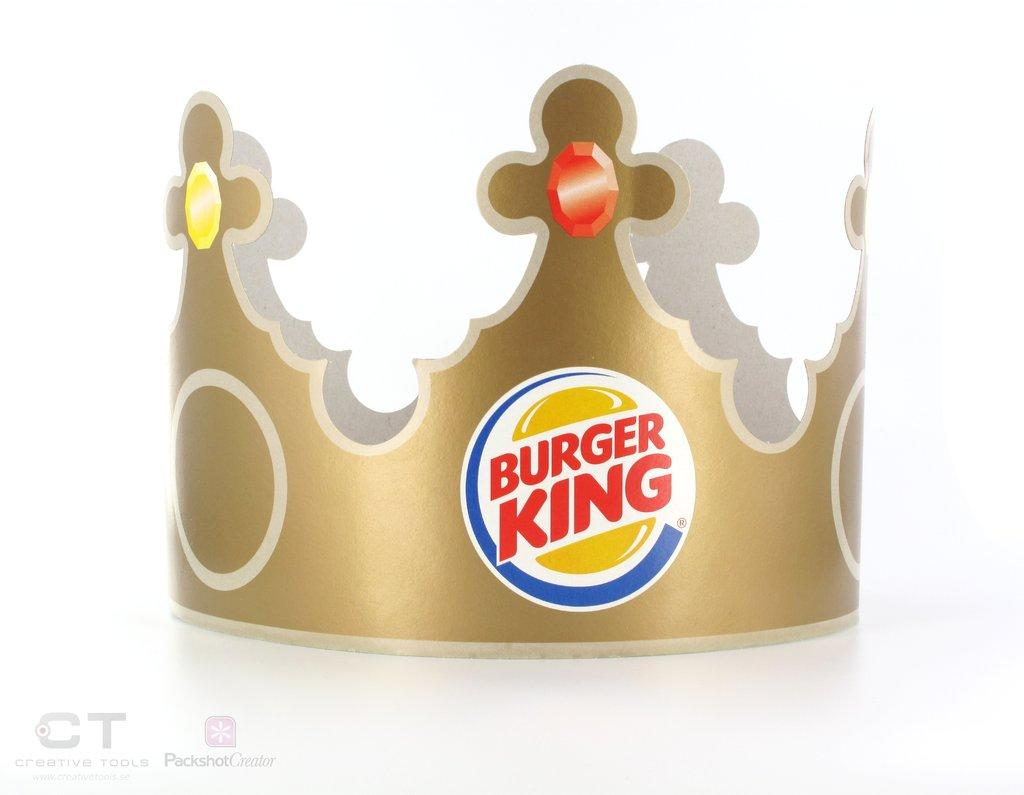What object in the image resembles a crown? There is an object in the image that resembles a crown. What is written on the crown-like object? There is text on the crown-like object. Can you describe any other text visible in the image? Yes, there is text visible in the image. What color is the background of the image? The background of the image is white. What type of toy is being invented in the image? There is no toy or invention process depicted in the image; it features a crown-like object with text and a white background. 